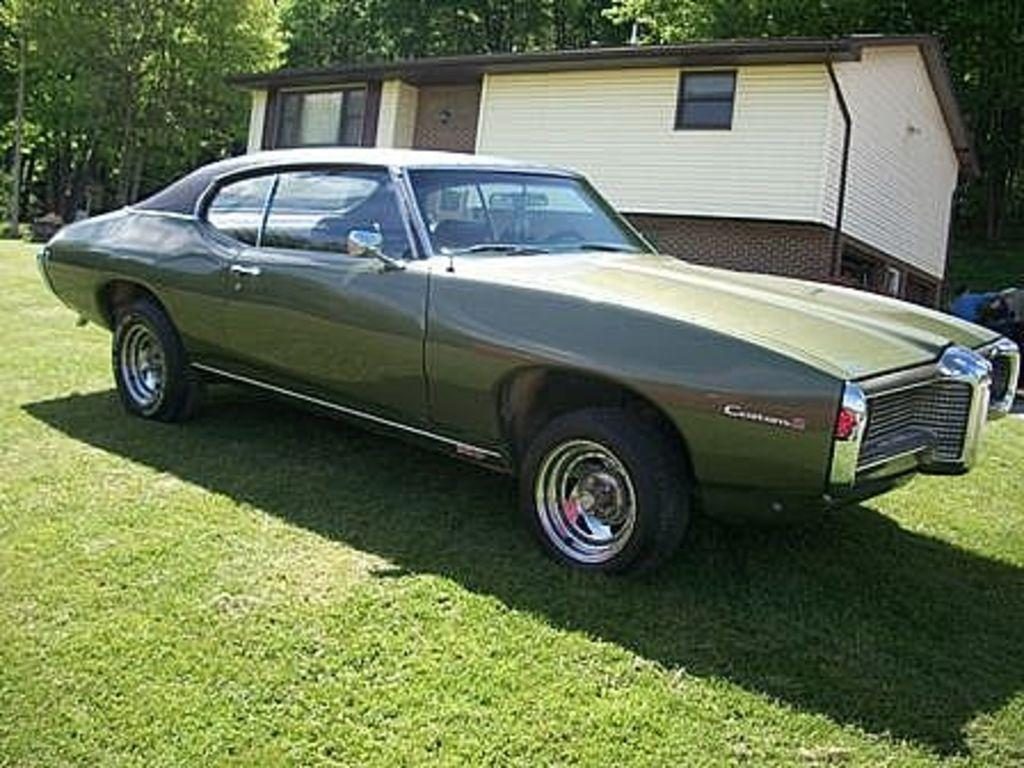What is the main subject of the image? There is a car in the image. Where is the car located? The car is parked on the grass. What is in front of the car? The car is in front of a house. What can be seen behind the house? There are trees behind the house. What type of celery is growing in the car's engine? There is no celery present in the image, and the car's engine is not visible. 